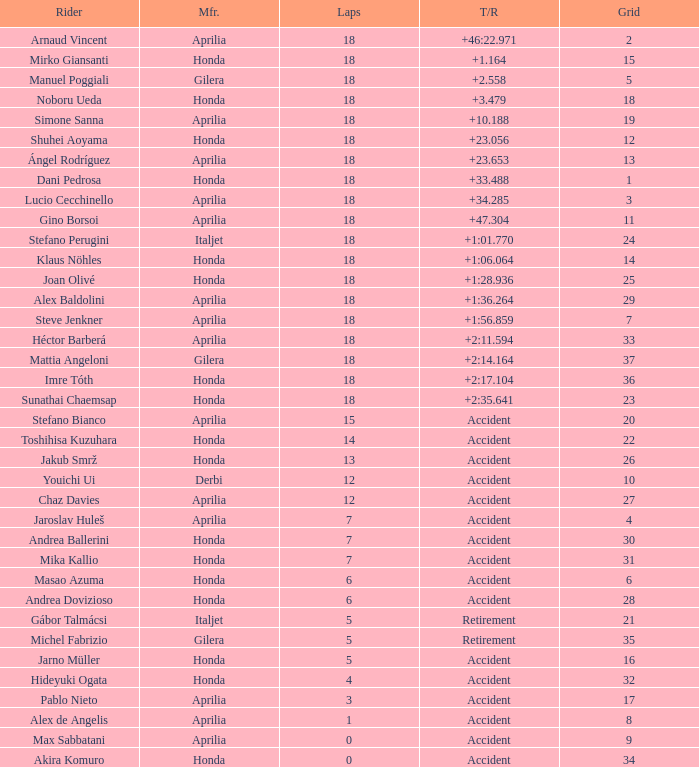What is the time/retired of the honda manufacturer with a grid less than 26, 18 laps, and joan olivé as the rider? +1:28.936. 